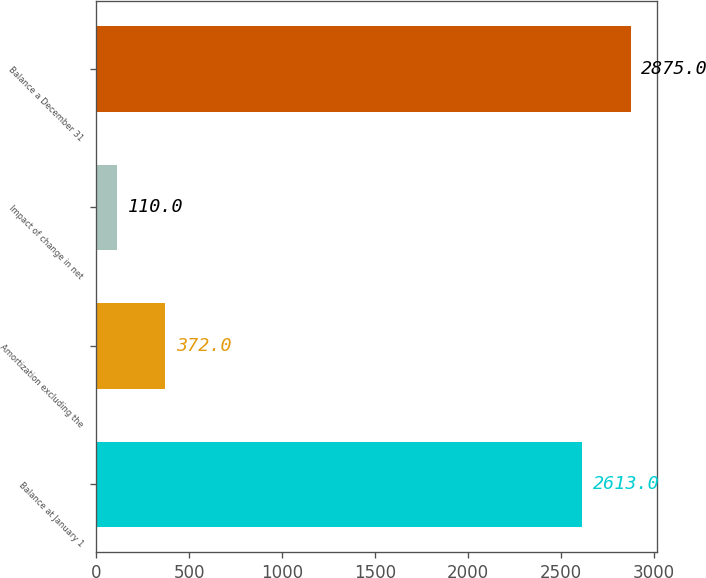Convert chart to OTSL. <chart><loc_0><loc_0><loc_500><loc_500><bar_chart><fcel>Balance at January 1<fcel>Amortization excluding the<fcel>Impact of change in net<fcel>Balance a December 31<nl><fcel>2613<fcel>372<fcel>110<fcel>2875<nl></chart> 